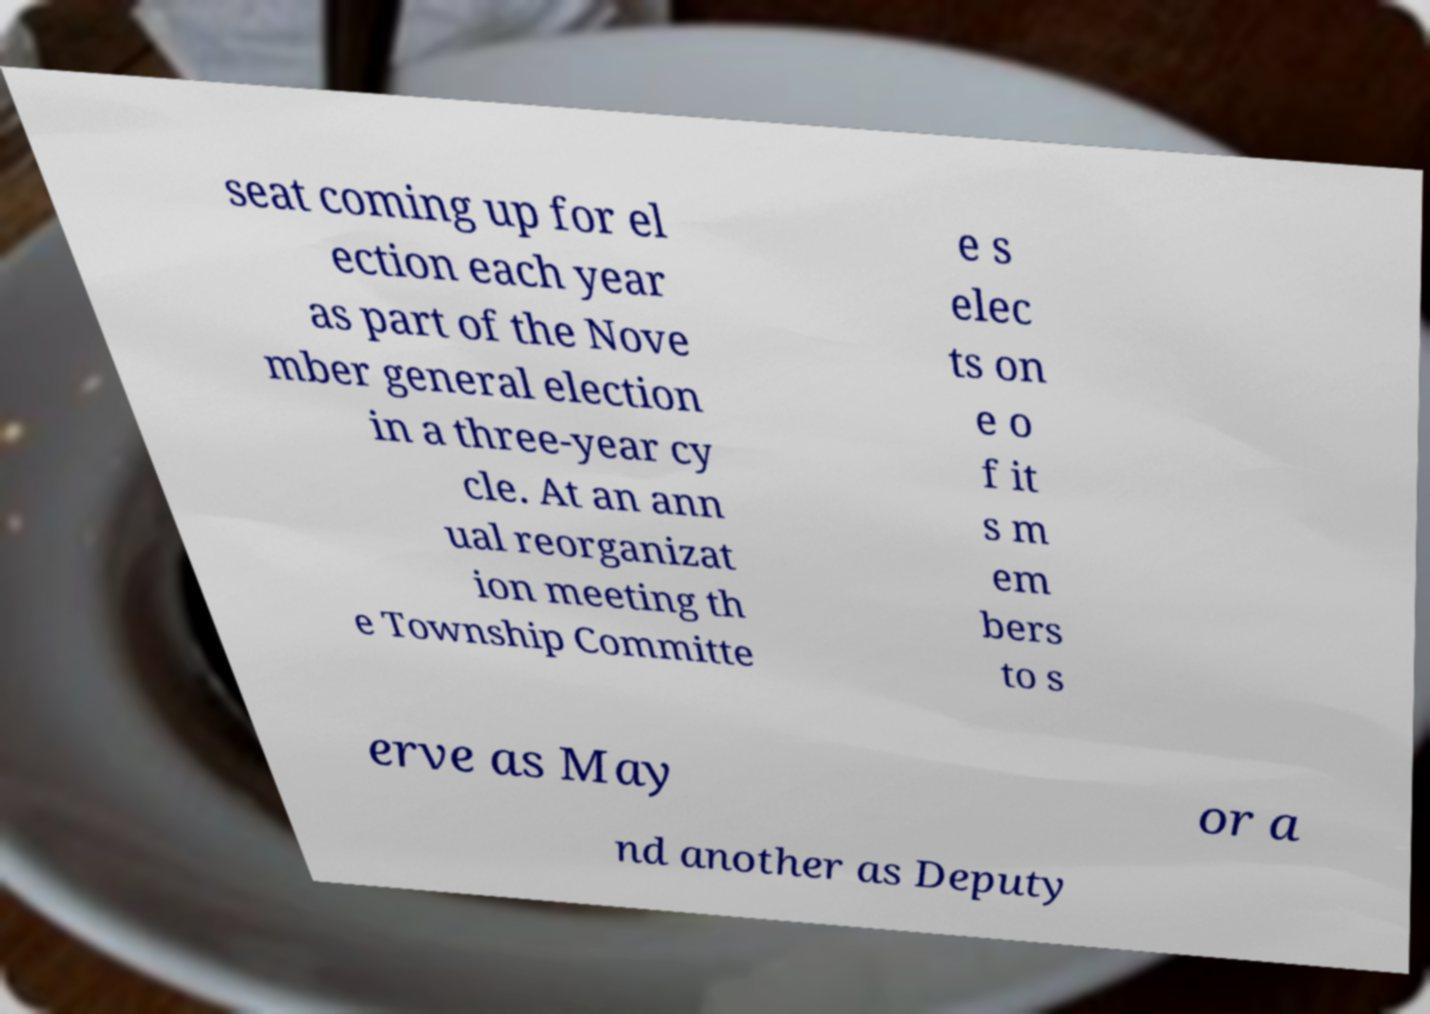Can you read and provide the text displayed in the image?This photo seems to have some interesting text. Can you extract and type it out for me? seat coming up for el ection each year as part of the Nove mber general election in a three-year cy cle. At an ann ual reorganizat ion meeting th e Township Committe e s elec ts on e o f it s m em bers to s erve as May or a nd another as Deputy 